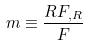Convert formula to latex. <formula><loc_0><loc_0><loc_500><loc_500>m \equiv \frac { R F _ { , R } } { F }</formula> 